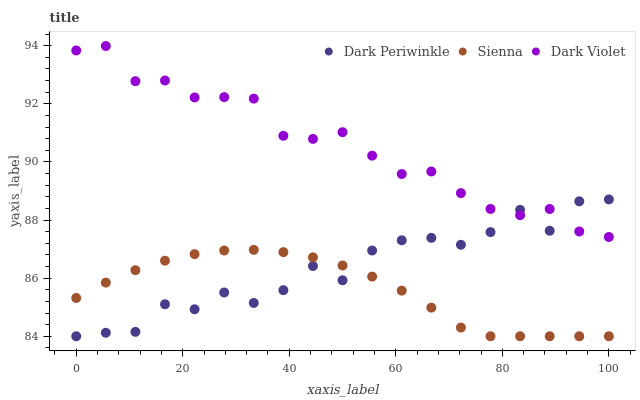Does Sienna have the minimum area under the curve?
Answer yes or no. Yes. Does Dark Violet have the maximum area under the curve?
Answer yes or no. Yes. Does Dark Periwinkle have the minimum area under the curve?
Answer yes or no. No. Does Dark Periwinkle have the maximum area under the curve?
Answer yes or no. No. Is Sienna the smoothest?
Answer yes or no. Yes. Is Dark Periwinkle the roughest?
Answer yes or no. Yes. Is Dark Violet the smoothest?
Answer yes or no. No. Is Dark Violet the roughest?
Answer yes or no. No. Does Sienna have the lowest value?
Answer yes or no. Yes. Does Dark Violet have the lowest value?
Answer yes or no. No. Does Dark Violet have the highest value?
Answer yes or no. Yes. Does Dark Periwinkle have the highest value?
Answer yes or no. No. Is Sienna less than Dark Violet?
Answer yes or no. Yes. Is Dark Violet greater than Sienna?
Answer yes or no. Yes. Does Sienna intersect Dark Periwinkle?
Answer yes or no. Yes. Is Sienna less than Dark Periwinkle?
Answer yes or no. No. Is Sienna greater than Dark Periwinkle?
Answer yes or no. No. Does Sienna intersect Dark Violet?
Answer yes or no. No. 